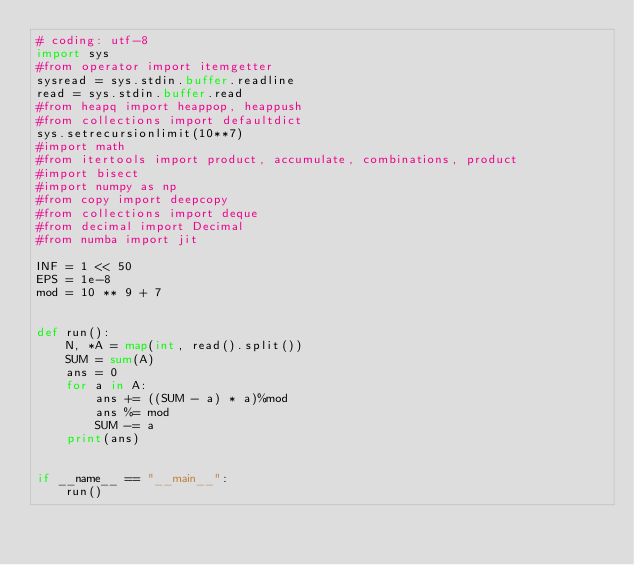Convert code to text. <code><loc_0><loc_0><loc_500><loc_500><_Python_># coding: utf-8
import sys
#from operator import itemgetter
sysread = sys.stdin.buffer.readline
read = sys.stdin.buffer.read
#from heapq import heappop, heappush
#from collections import defaultdict
sys.setrecursionlimit(10**7)
#import math
#from itertools import product, accumulate, combinations, product
#import bisect
#import numpy as np
#from copy import deepcopy
#from collections import deque
#from decimal import Decimal
#from numba import jit

INF = 1 << 50
EPS = 1e-8
mod = 10 ** 9 + 7


def run():
    N, *A = map(int, read().split())
    SUM = sum(A)
    ans = 0
    for a in A:
        ans += ((SUM - a) * a)%mod
        ans %= mod
        SUM -= a
    print(ans)


if __name__ == "__main__":
    run()</code> 